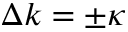Convert formula to latex. <formula><loc_0><loc_0><loc_500><loc_500>\Delta k = \pm \kappa</formula> 